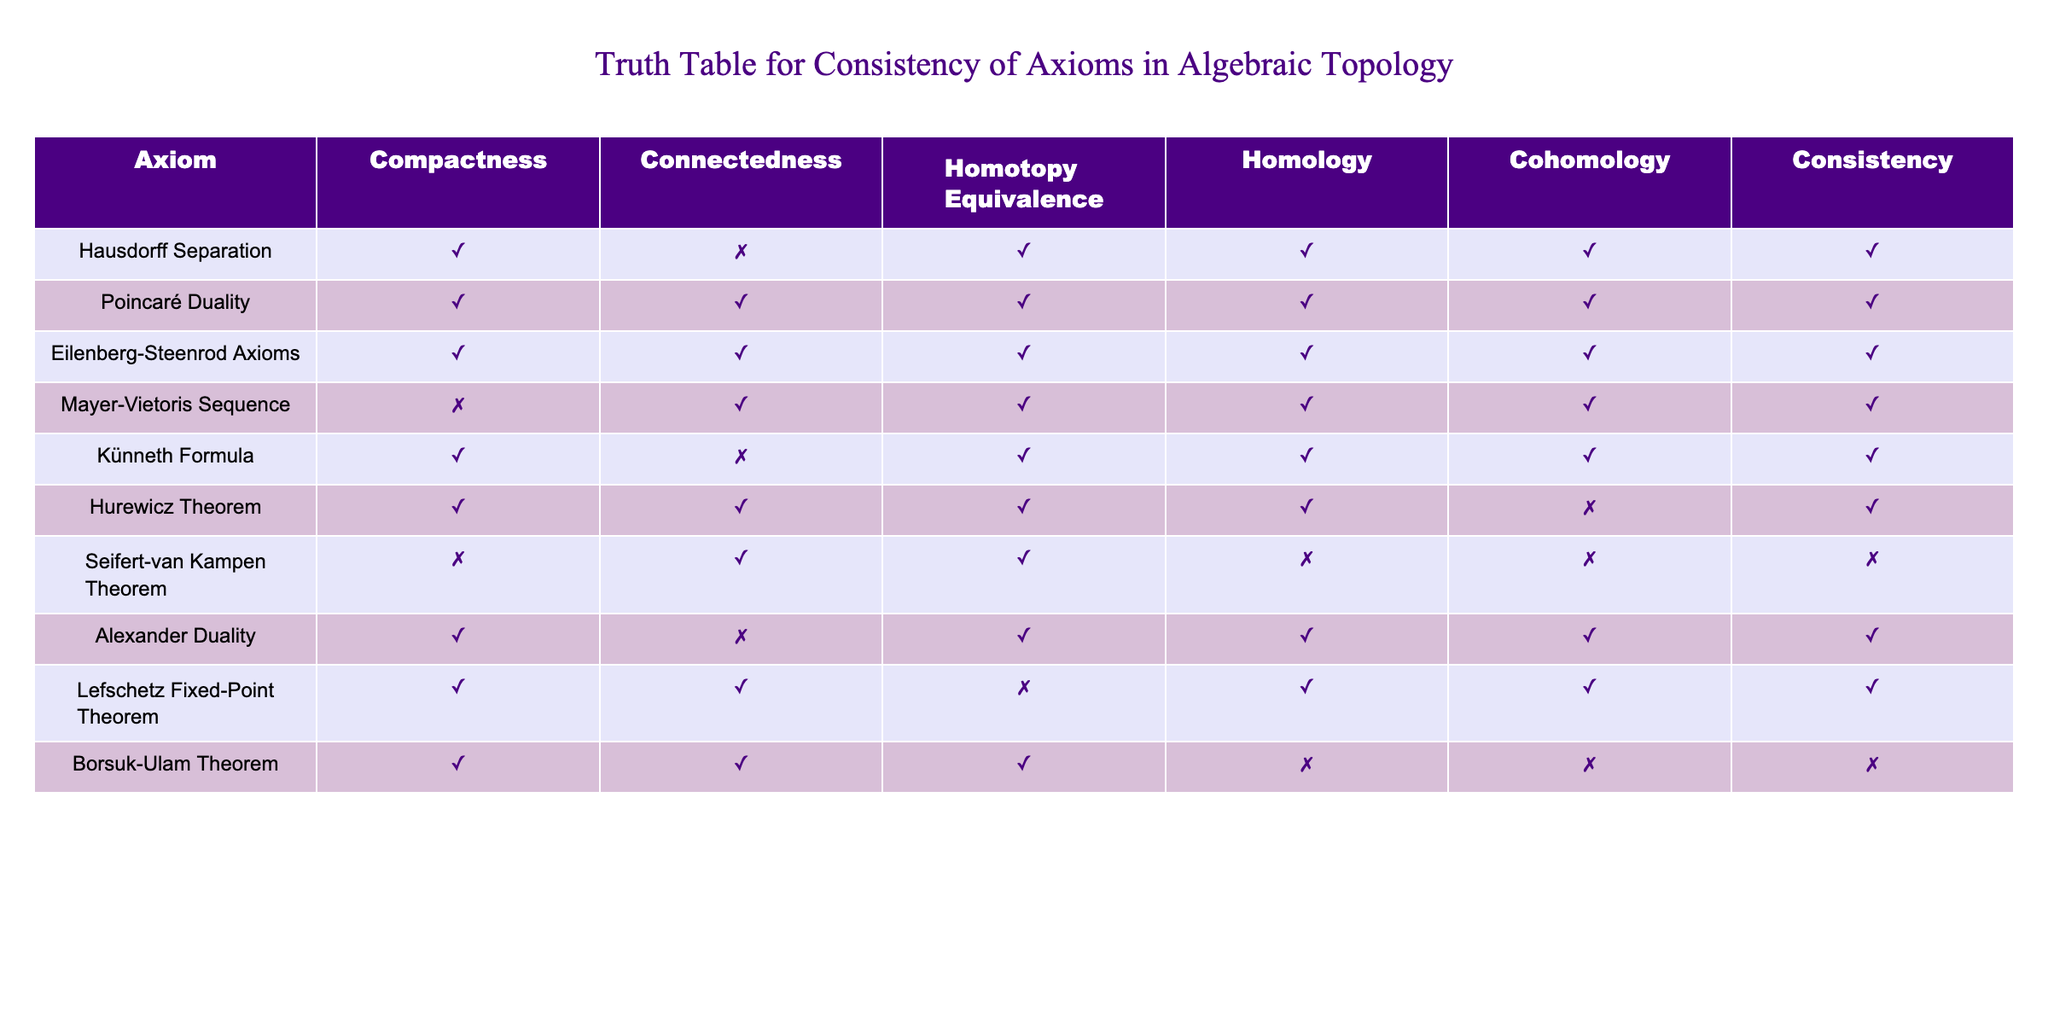What is the consistency status of the Hausdorff Separation axiom? Looking at the row for Hausdorff Separation, we see that it has a consistent status marked as TRUE.
Answer: TRUE Which axioms demonstrate the property of Compactness as TRUE? By examining the table, we can observe that the following axioms have a TRUE value for Compactness: Hausdorff Separation, Poincaré Duality, Eilenberg-Steenrod Axioms, Künneth Formula, Hurewicz Theorem, Alexander Duality, and Lefschetz Fixed-Point Theorem. This gives us a total of 7 axioms.
Answer: 7 Is the Homology status of the Seifert-van Kampen Theorem TRUE or FALSE? In the row for Seifert-van Kampen Theorem, the Homology status is denoted as FALSE.
Answer: FALSE How many axioms are inconsistent based on the table? To find the inconsistent axioms, we check the Consistency column. Counting the rows with FALSE in Consistency gives: Seifert-van Kampen Theorem, Hurewicz Theorem, and Borsuk-Ulam Theorem, leading to a total of 3 inconsistent axioms.
Answer: 3 Which axiom has the Homotopy Equivalence status marked as FALSE? Observing the column for Homotopy Equivalence, we find that the Lefschetz Fixed-Point Theorem is the only axiom with this status marked as FALSE.
Answer: Lefschetz Fixed-Point Theorem How does the number of axioms with both Compactness and Connectedness compare to those with only Compactness? The axioms that have both Compactness and Connectedness marked as TRUE are Poincaré Duality, Eilenberg-Steenrod Axioms, and Hurewicz Theorem, totaling 3 axioms. The only axiom with Compactness as TRUE but Connectedness as FALSE is Künneth Formula. Therefore, we have 3 axioms with both properties and 1 with only Compactness. The comparison shows that there are 3 axioms with both and 1 with only Compactness.
Answer: 3 vs 1 What is the maximum consistency value among the axioms? Looking at the Consistency column, we see that all the axioms except for Seifert-van Kampen Theorem, Hurewicz Theorem, and Borsuk-Ulam Theorem have a consistency status of TRUE. The highest consistency value among the axioms is marked as TRUE.
Answer: TRUE Is there any axiom that shows TRUE for all properties except for one? Analyzing the rows, we find that the Hurewicz Theorem shows TRUE for all properties except for Cohomology, which is marked FALSE. This indicates it has only one property that is inconsistent while all the others are consistent.
Answer: Hurewicz Theorem Identify an axiom with all properties marked as TRUE. In the table, Poincaré Duality is the axiom that has all properties: Compactness, Connectedness, Homotopy Equivalence, Homology, and Cohomology marked as TRUE.
Answer: Poincaré Duality 